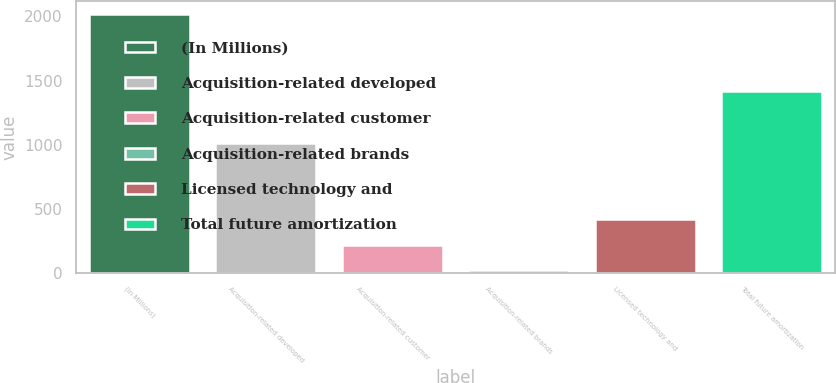<chart> <loc_0><loc_0><loc_500><loc_500><bar_chart><fcel>(In Millions)<fcel>Acquisition-related developed<fcel>Acquisition-related customer<fcel>Acquisition-related brands<fcel>Licensed technology and<fcel>Total future amortization<nl><fcel>2020<fcel>1011<fcel>220<fcel>20<fcel>420<fcel>1421<nl></chart> 